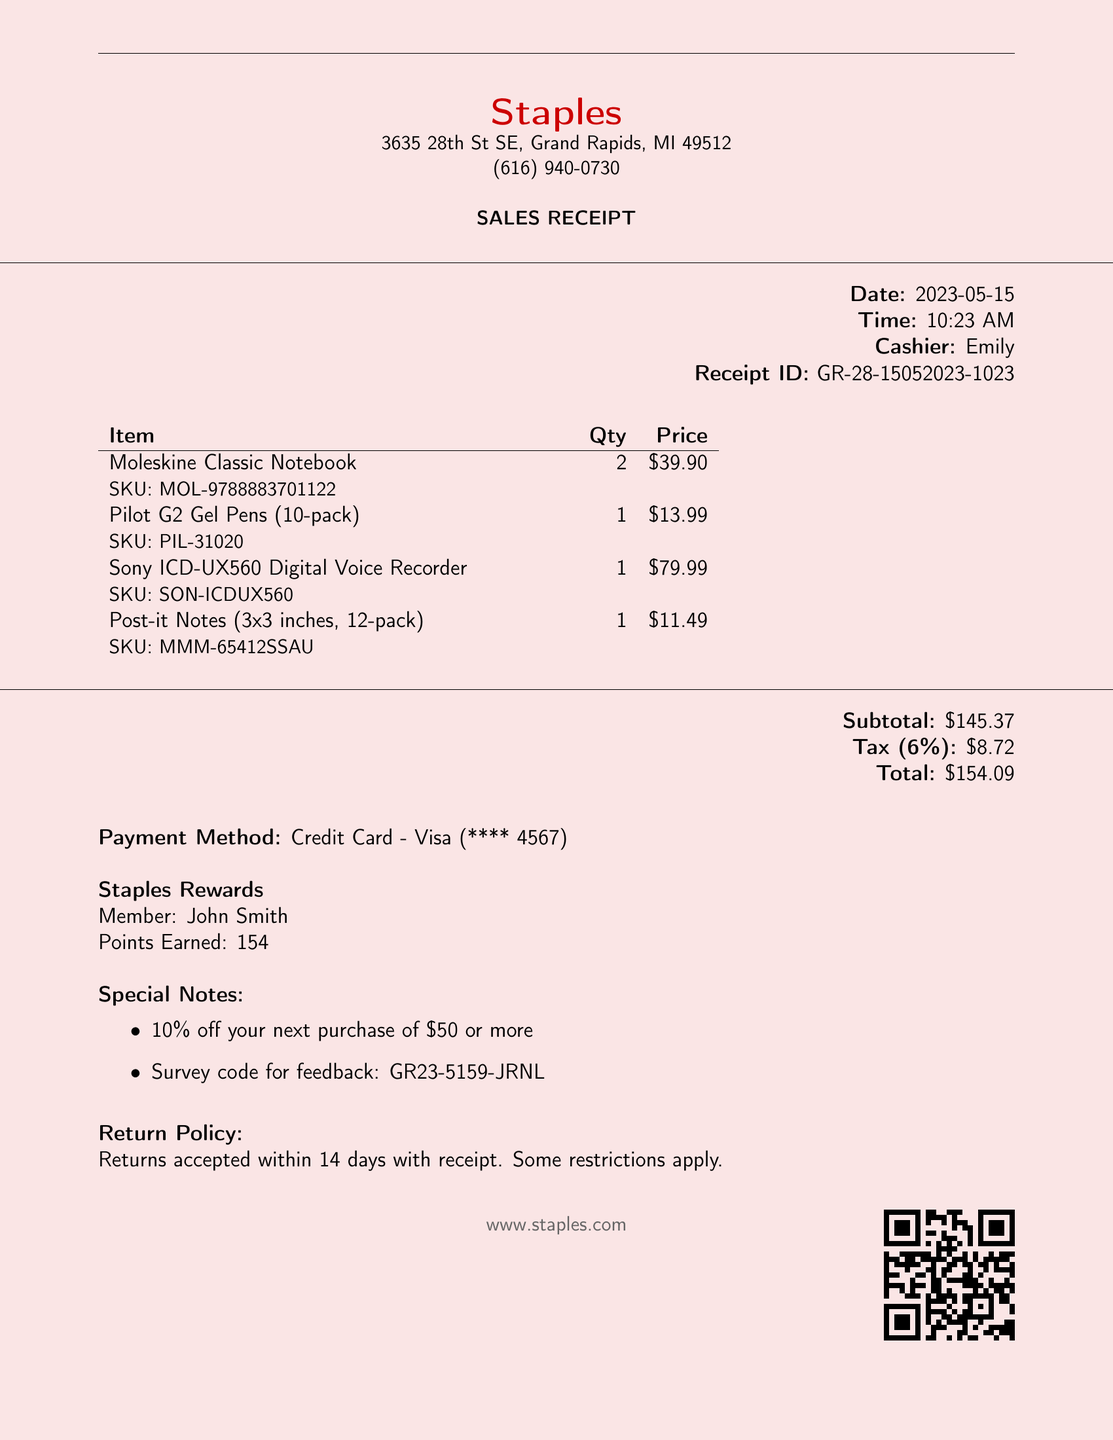What is the store name? The store name is prominently displayed at the top of the document.
Answer: Staples What city is the store located in? The address section of the receipt specifies the city.
Answer: Grand Rapids Who was the cashier during this transaction? The cashier's name is listed in the details section.
Answer: Emily What is the total amount spent? The total is calculated in the summary section of the receipt.
Answer: $154.09 How many Moleskine Classic Notebooks were purchased? The quantity is noted beside the item description.
Answer: 2 What was the tax rate applied to the purchase? The tax rate is listed in the total breakdown section.
Answer: 6% Which payment method was used for this transaction? The payment information is stated under the payment method section.
Answer: Credit Card - Visa What is the return policy stated on the receipt? The return policy details are included at the bottom of the document.
Answer: Returns accepted within 14 days with receipt How many points were earned in the Staples Rewards program? The points earned are specifically mentioned in the rewards section.
Answer: 154 What is the survey code provided for feedback? The survey code is one of the special notes mentioned in the document.
Answer: GR23-5159-JRNL 